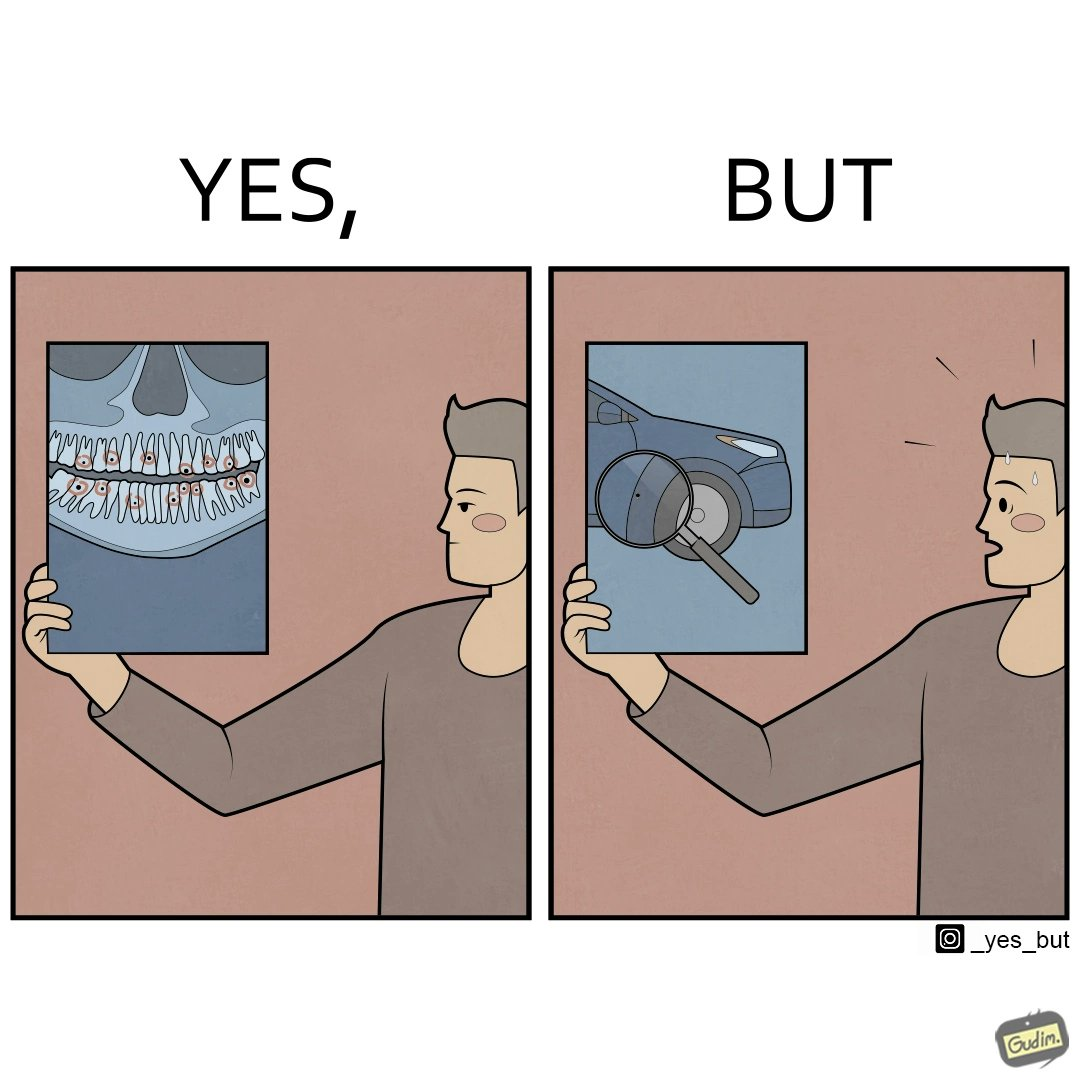Explain the humor or irony in this image. The images are funny since they show how people are more worried about small damages to  things they can replace like cars but are not worried about permanent damages to their own health 